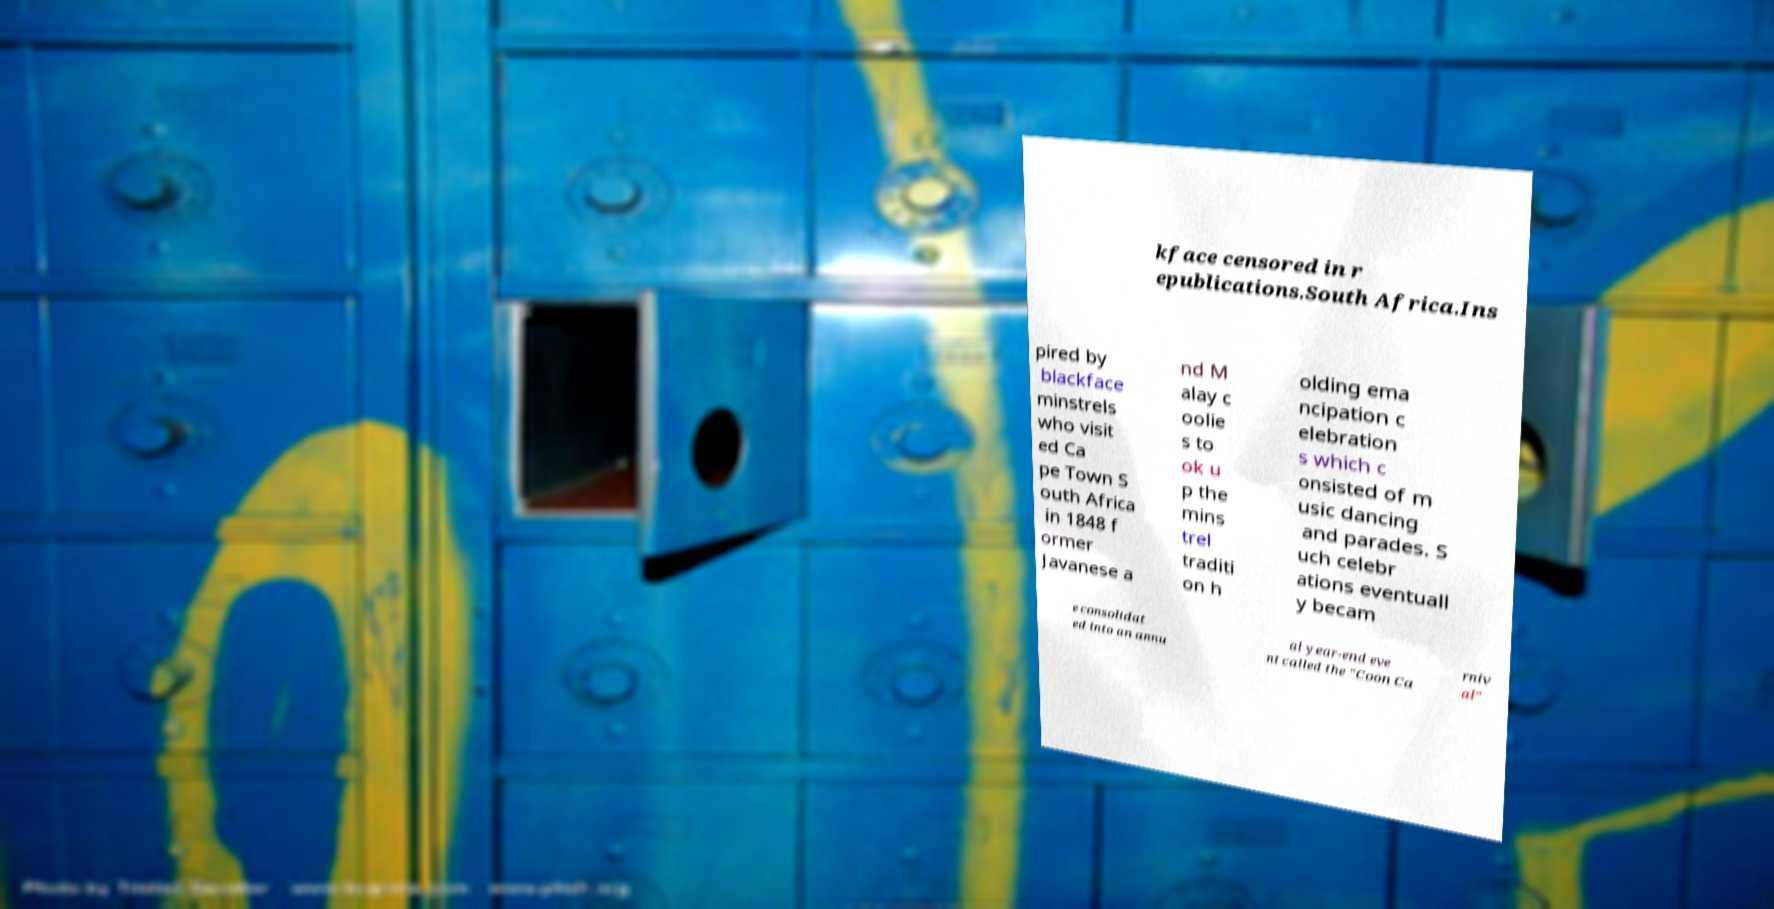Please read and relay the text visible in this image. What does it say? kface censored in r epublications.South Africa.Ins pired by blackface minstrels who visit ed Ca pe Town S outh Africa in 1848 f ormer Javanese a nd M alay c oolie s to ok u p the mins trel traditi on h olding ema ncipation c elebration s which c onsisted of m usic dancing and parades. S uch celebr ations eventuall y becam e consolidat ed into an annu al year-end eve nt called the "Coon Ca rniv al" 